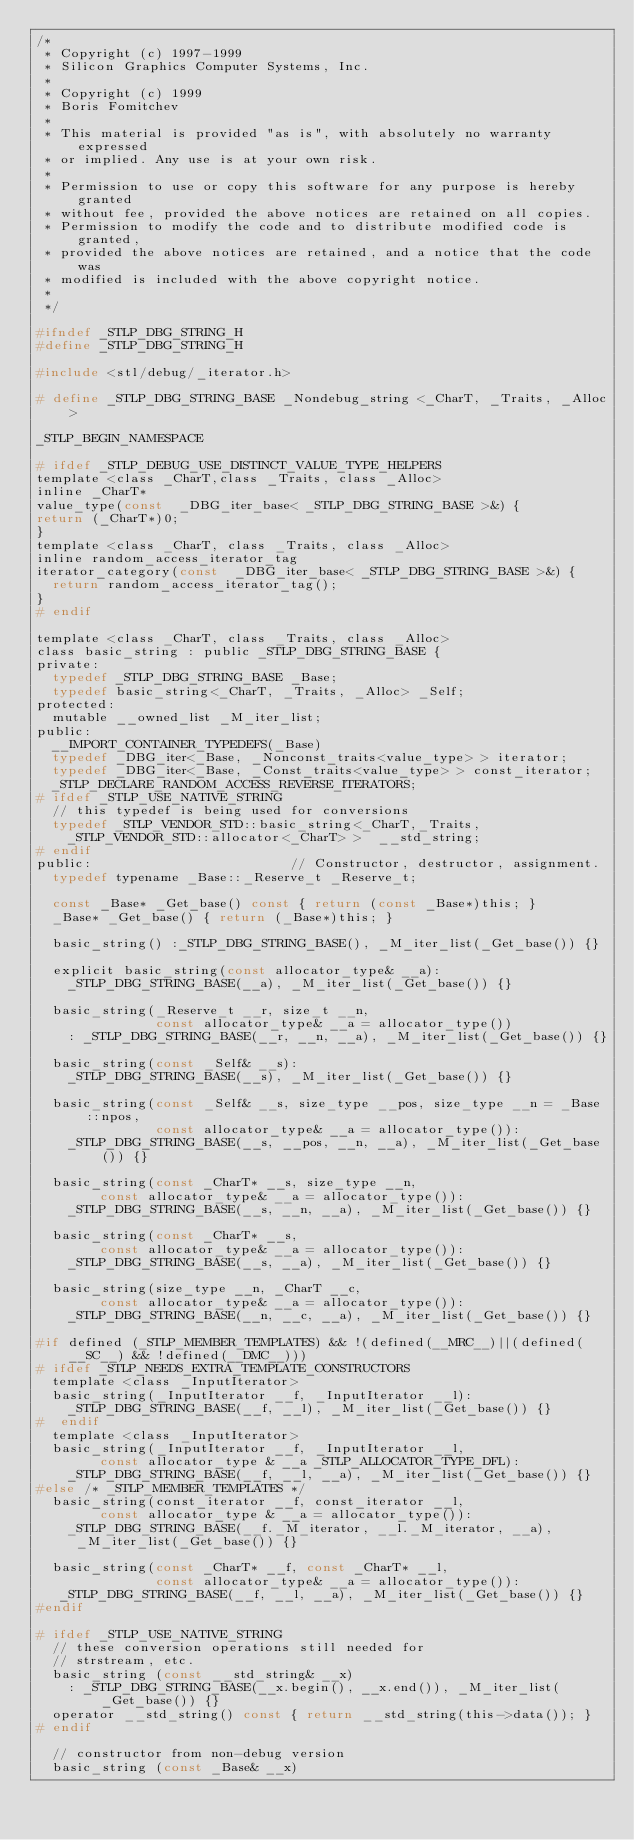<code> <loc_0><loc_0><loc_500><loc_500><_C_>/*
 * Copyright (c) 1997-1999
 * Silicon Graphics Computer Systems, Inc.
 *
 * Copyright (c) 1999 
 * Boris Fomitchev
 *
 * This material is provided "as is", with absolutely no warranty expressed
 * or implied. Any use is at your own risk.
 *
 * Permission to use or copy this software for any purpose is hereby granted 
 * without fee, provided the above notices are retained on all copies.
 * Permission to modify the code and to distribute modified code is granted,
 * provided the above notices are retained, and a notice that the code was
 * modified is included with the above copyright notice.
 *
 */

#ifndef _STLP_DBG_STRING_H
#define _STLP_DBG_STRING_H

#include <stl/debug/_iterator.h>

# define _STLP_DBG_STRING_BASE _Nondebug_string <_CharT, _Traits, _Alloc>

_STLP_BEGIN_NAMESPACE

# ifdef _STLP_DEBUG_USE_DISTINCT_VALUE_TYPE_HELPERS
template <class _CharT,class _Traits, class _Alloc>
inline _CharT*
value_type(const  _DBG_iter_base< _STLP_DBG_STRING_BASE >&) {
return (_CharT*)0;
}
template <class _CharT, class _Traits, class _Alloc>
inline random_access_iterator_tag
iterator_category(const  _DBG_iter_base< _STLP_DBG_STRING_BASE >&) {
  return random_access_iterator_tag();
}
# endif

template <class _CharT, class _Traits, class _Alloc> 
class basic_string : public _STLP_DBG_STRING_BASE {
private:
  typedef _STLP_DBG_STRING_BASE _Base;
  typedef basic_string<_CharT, _Traits, _Alloc> _Self;
protected:
  mutable __owned_list _M_iter_list;
public:
  __IMPORT_CONTAINER_TYPEDEFS(_Base)
  typedef _DBG_iter<_Base, _Nonconst_traits<value_type> > iterator;
  typedef _DBG_iter<_Base, _Const_traits<value_type> > const_iterator;
  _STLP_DECLARE_RANDOM_ACCESS_REVERSE_ITERATORS;
# ifdef _STLP_USE_NATIVE_STRING
  // this typedef is being used for conversions
  typedef _STLP_VENDOR_STD::basic_string<_CharT,_Traits, 
    _STLP_VENDOR_STD::allocator<_CharT> >  __std_string;
# endif
public:                         // Constructor, destructor, assignment.
  typedef typename _Base::_Reserve_t _Reserve_t;

  const _Base* _Get_base() const { return (const _Base*)this; }
  _Base* _Get_base() { return (_Base*)this; }

  basic_string() :_STLP_DBG_STRING_BASE(), _M_iter_list(_Get_base()) {}
  
  explicit basic_string(const allocator_type& __a): 
    _STLP_DBG_STRING_BASE(__a), _M_iter_list(_Get_base()) {}

  basic_string(_Reserve_t __r, size_t __n,
               const allocator_type& __a = allocator_type())
    : _STLP_DBG_STRING_BASE(__r, __n, __a), _M_iter_list(_Get_base()) {}

  basic_string(const _Self& __s): 
    _STLP_DBG_STRING_BASE(__s), _M_iter_list(_Get_base()) {}

  basic_string(const _Self& __s, size_type __pos, size_type __n = _Base::npos,
               const allocator_type& __a = allocator_type()):
    _STLP_DBG_STRING_BASE(__s, __pos, __n, __a), _M_iter_list(_Get_base()) {}

  basic_string(const _CharT* __s, size_type __n,
		    const allocator_type& __a = allocator_type()):
    _STLP_DBG_STRING_BASE(__s, __n, __a), _M_iter_list(_Get_base()) {}

  basic_string(const _CharT* __s,
		    const allocator_type& __a = allocator_type()):
    _STLP_DBG_STRING_BASE(__s, __a), _M_iter_list(_Get_base()) {}

  basic_string(size_type __n, _CharT __c,
		    const allocator_type& __a = allocator_type()):
    _STLP_DBG_STRING_BASE(__n, __c, __a), _M_iter_list(_Get_base()) {}

#if defined (_STLP_MEMBER_TEMPLATES) && !(defined(__MRC__)||(defined(__SC__) && !defined(__DMC__)))
# ifdef _STLP_NEEDS_EXTRA_TEMPLATE_CONSTRUCTORS
  template <class _InputIterator>
  basic_string(_InputIterator __f, _InputIterator __l):
    _STLP_DBG_STRING_BASE(__f, __l), _M_iter_list(_Get_base()) {}
#  endif
  template <class _InputIterator>
  basic_string(_InputIterator __f, _InputIterator __l,
		    const allocator_type & __a _STLP_ALLOCATOR_TYPE_DFL):
    _STLP_DBG_STRING_BASE(__f, __l, __a), _M_iter_list(_Get_base()) {}
#else /* _STLP_MEMBER_TEMPLATES */
  basic_string(const_iterator __f, const_iterator __l, 
		    const allocator_type & __a = allocator_type()):
    _STLP_DBG_STRING_BASE(__f._M_iterator, __l._M_iterator, __a), 
     _M_iter_list(_Get_base()) {}

  basic_string(const _CharT* __f, const _CharT* __l,
               const allocator_type& __a = allocator_type()):
   _STLP_DBG_STRING_BASE(__f, __l, __a), _M_iter_list(_Get_base()) {}
#endif

# ifdef _STLP_USE_NATIVE_STRING
  // these conversion operations still needed for
  // strstream, etc.
  basic_string (const __std_string& __x)
    : _STLP_DBG_STRING_BASE(__x.begin(), __x.end()), _M_iter_list(_Get_base()) {}
  operator __std_string() const { return __std_string(this->data()); }
# endif

  // constructor from non-debug version
  basic_string (const _Base& __x)</code> 